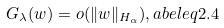Convert formula to latex. <formula><loc_0><loc_0><loc_500><loc_500>G _ { \lambda } ( w ) = o ( \| w \| _ { H _ { \alpha } } ) , \L a b e l { e q 2 . 4 }</formula> 